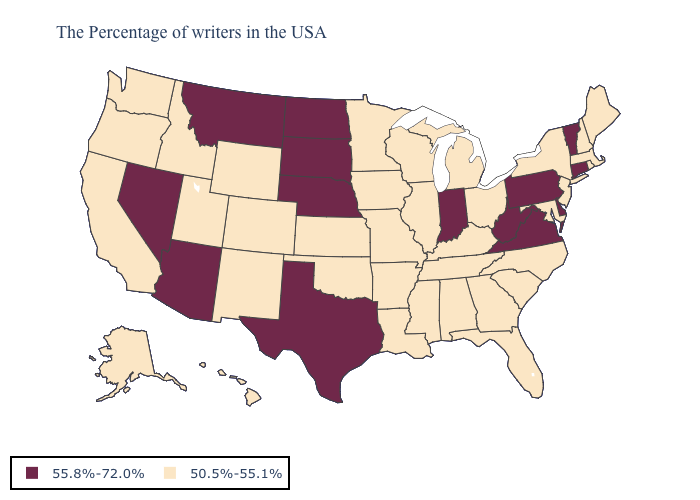Which states have the highest value in the USA?
Write a very short answer. Vermont, Connecticut, Delaware, Pennsylvania, Virginia, West Virginia, Indiana, Nebraska, Texas, South Dakota, North Dakota, Montana, Arizona, Nevada. Name the states that have a value in the range 50.5%-55.1%?
Write a very short answer. Maine, Massachusetts, Rhode Island, New Hampshire, New York, New Jersey, Maryland, North Carolina, South Carolina, Ohio, Florida, Georgia, Michigan, Kentucky, Alabama, Tennessee, Wisconsin, Illinois, Mississippi, Louisiana, Missouri, Arkansas, Minnesota, Iowa, Kansas, Oklahoma, Wyoming, Colorado, New Mexico, Utah, Idaho, California, Washington, Oregon, Alaska, Hawaii. Among the states that border Colorado , which have the lowest value?
Give a very brief answer. Kansas, Oklahoma, Wyoming, New Mexico, Utah. What is the value of Nebraska?
Quick response, please. 55.8%-72.0%. Name the states that have a value in the range 50.5%-55.1%?
Give a very brief answer. Maine, Massachusetts, Rhode Island, New Hampshire, New York, New Jersey, Maryland, North Carolina, South Carolina, Ohio, Florida, Georgia, Michigan, Kentucky, Alabama, Tennessee, Wisconsin, Illinois, Mississippi, Louisiana, Missouri, Arkansas, Minnesota, Iowa, Kansas, Oklahoma, Wyoming, Colorado, New Mexico, Utah, Idaho, California, Washington, Oregon, Alaska, Hawaii. Does Georgia have the highest value in the South?
Answer briefly. No. Does the map have missing data?
Be succinct. No. What is the lowest value in the USA?
Write a very short answer. 50.5%-55.1%. Among the states that border North Dakota , does South Dakota have the highest value?
Quick response, please. Yes. Does Delaware have a higher value than North Dakota?
Short answer required. No. Which states have the highest value in the USA?
Be succinct. Vermont, Connecticut, Delaware, Pennsylvania, Virginia, West Virginia, Indiana, Nebraska, Texas, South Dakota, North Dakota, Montana, Arizona, Nevada. Does New Hampshire have the same value as North Carolina?
Answer briefly. Yes. What is the value of Montana?
Give a very brief answer. 55.8%-72.0%. What is the value of Wisconsin?
Give a very brief answer. 50.5%-55.1%. Does the first symbol in the legend represent the smallest category?
Answer briefly. No. 